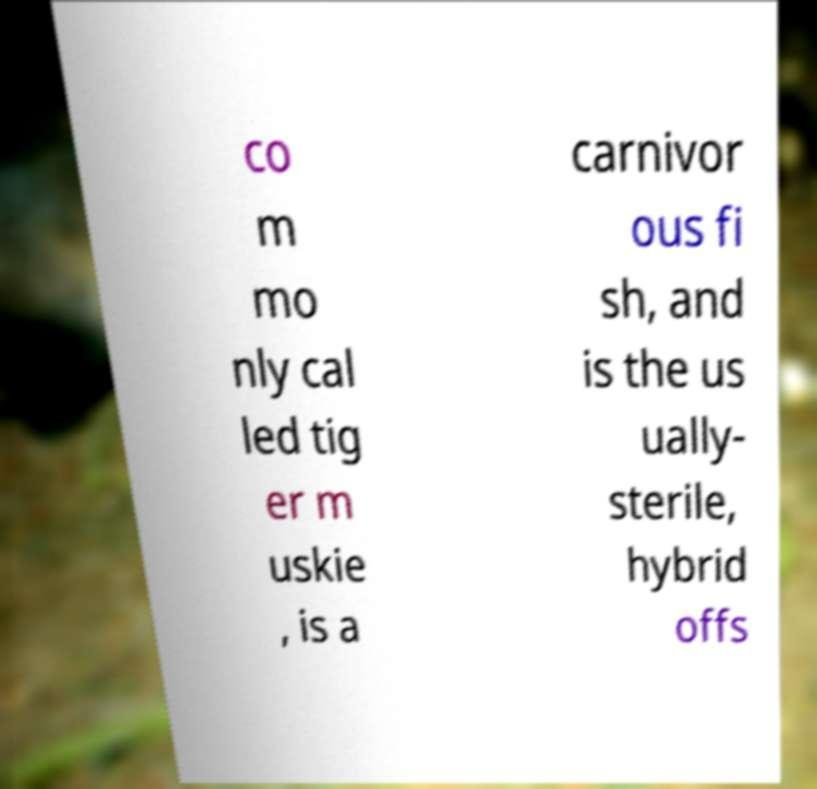Can you read and provide the text displayed in the image?This photo seems to have some interesting text. Can you extract and type it out for me? co m mo nly cal led tig er m uskie , is a carnivor ous fi sh, and is the us ually- sterile, hybrid offs 